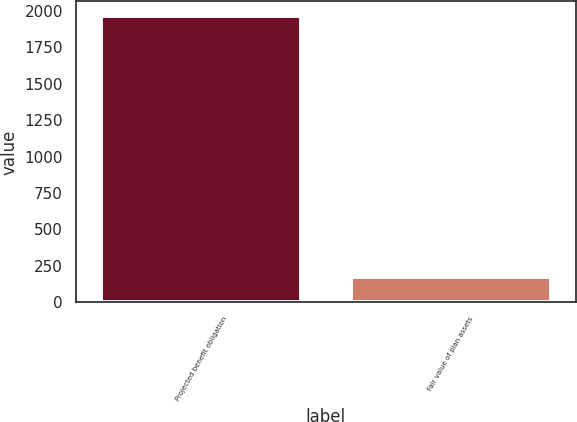Convert chart to OTSL. <chart><loc_0><loc_0><loc_500><loc_500><bar_chart><fcel>Projected benefit obligation<fcel>Fair value of plan assets<nl><fcel>1964<fcel>177<nl></chart> 